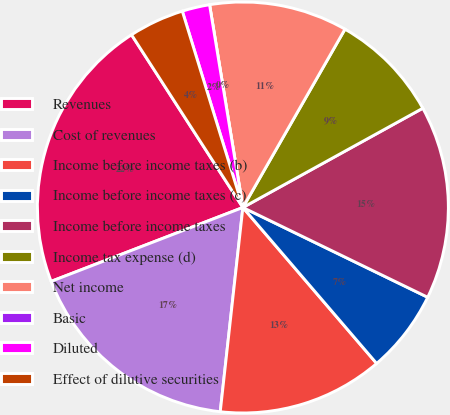Convert chart to OTSL. <chart><loc_0><loc_0><loc_500><loc_500><pie_chart><fcel>Revenues<fcel>Cost of revenues<fcel>Income before income taxes (b)<fcel>Income before income taxes (c)<fcel>Income before income taxes<fcel>Income tax expense (d)<fcel>Net income<fcel>Basic<fcel>Diluted<fcel>Effect of dilutive securities<nl><fcel>21.74%<fcel>17.39%<fcel>13.04%<fcel>6.52%<fcel>15.22%<fcel>8.7%<fcel>10.87%<fcel>0.0%<fcel>2.17%<fcel>4.35%<nl></chart> 